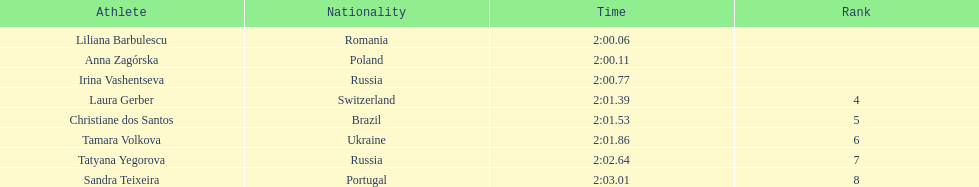The last runner crossed the finish line in 2:03.01. what was the previous time for the 7th runner? 2:02.64. 